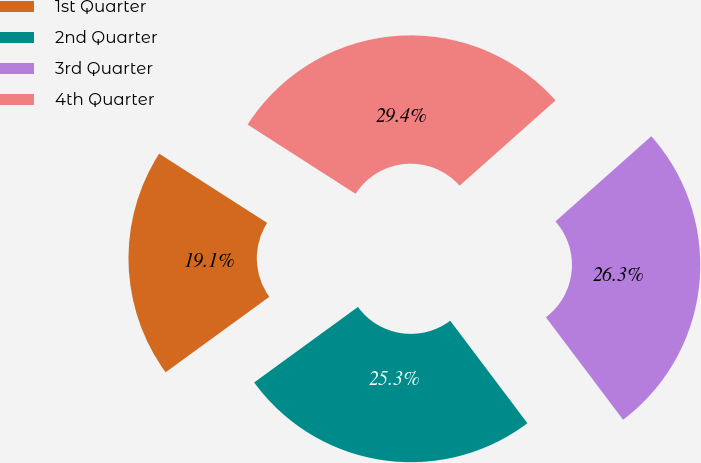<chart> <loc_0><loc_0><loc_500><loc_500><pie_chart><fcel>1st Quarter<fcel>2nd Quarter<fcel>3rd Quarter<fcel>4th Quarter<nl><fcel>19.09%<fcel>25.26%<fcel>26.29%<fcel>29.36%<nl></chart> 